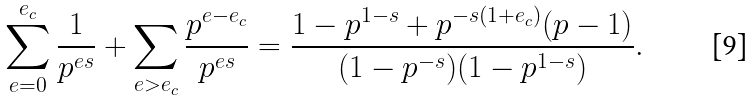<formula> <loc_0><loc_0><loc_500><loc_500>\sum _ { e = 0 } ^ { e _ { c } } \frac { 1 } { p ^ { e s } } + \sum _ { e > e _ { c } } \frac { p ^ { e - e _ { c } } } { p ^ { e s } } = \frac { 1 - p ^ { 1 - s } + p ^ { - s ( 1 + e _ { c } ) } ( p - 1 ) } { ( 1 - p ^ { - s } ) ( 1 - p ^ { 1 - s } ) } .</formula> 